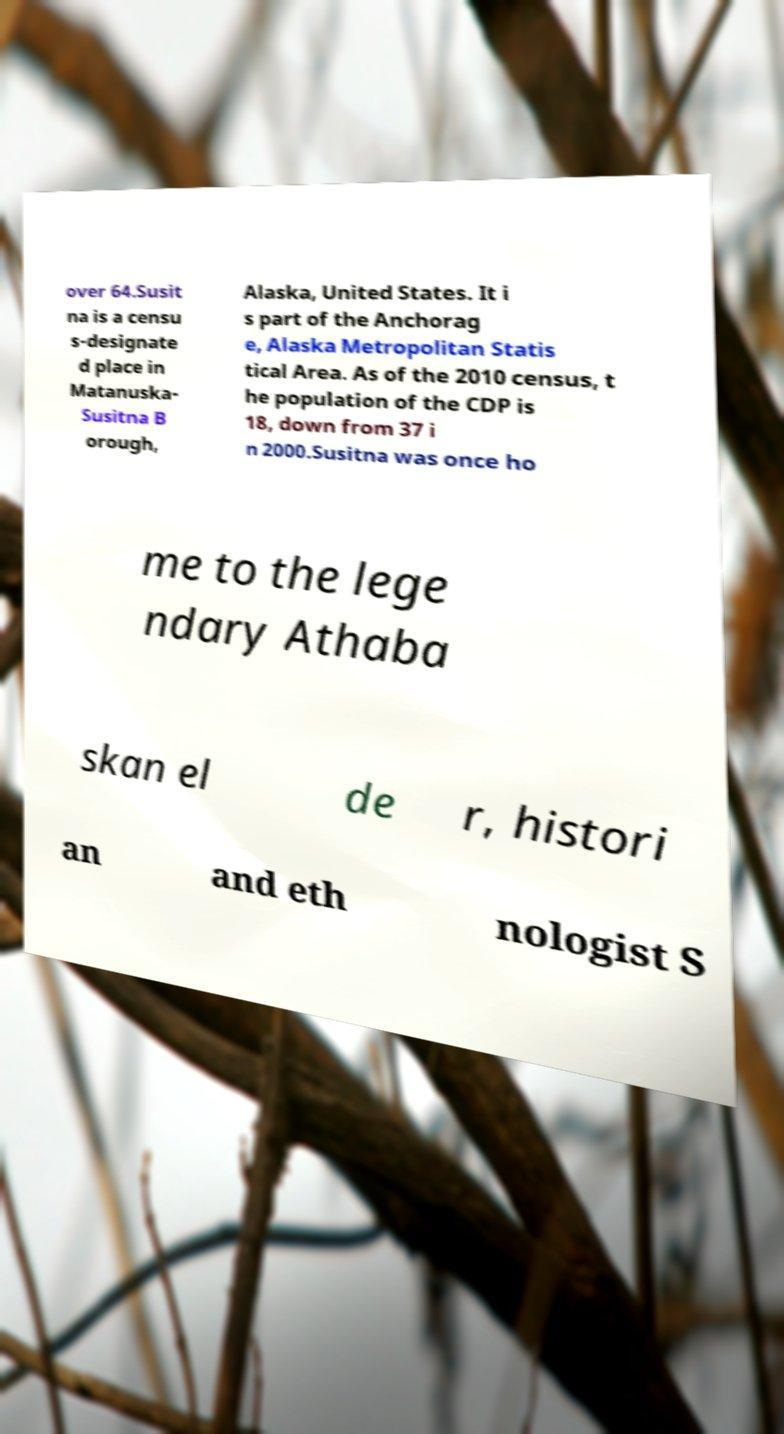What messages or text are displayed in this image? I need them in a readable, typed format. over 64.Susit na is a censu s-designate d place in Matanuska- Susitna B orough, Alaska, United States. It i s part of the Anchorag e, Alaska Metropolitan Statis tical Area. As of the 2010 census, t he population of the CDP is 18, down from 37 i n 2000.Susitna was once ho me to the lege ndary Athaba skan el de r, histori an and eth nologist S 